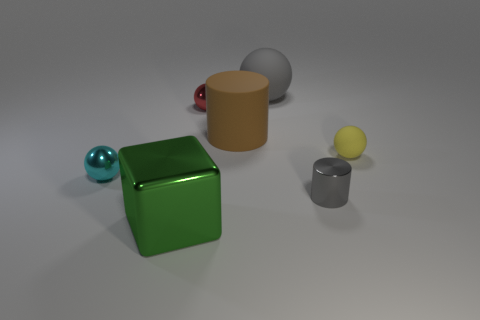Add 3 metallic cubes. How many objects exist? 10 Subtract all big matte balls. How many balls are left? 3 Subtract all cylinders. How many objects are left? 5 Subtract all brown cubes. Subtract all big objects. How many objects are left? 4 Add 2 small gray metallic cylinders. How many small gray metallic cylinders are left? 3 Add 3 brown matte things. How many brown matte things exist? 4 Subtract all brown cylinders. How many cylinders are left? 1 Subtract 1 red spheres. How many objects are left? 6 Subtract 1 blocks. How many blocks are left? 0 Subtract all brown cylinders. Subtract all brown balls. How many cylinders are left? 1 